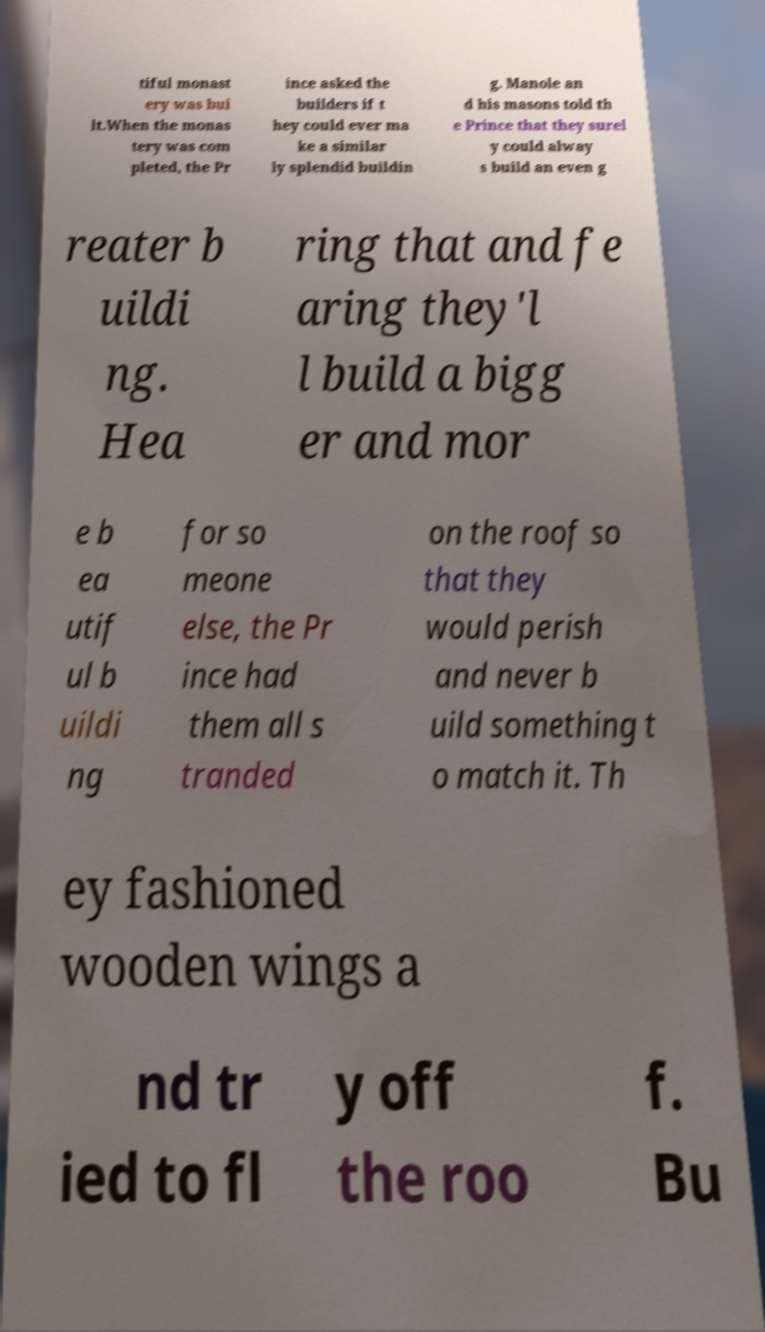Could you extract and type out the text from this image? tiful monast ery was bui lt.When the monas tery was com pleted, the Pr ince asked the builders if t hey could ever ma ke a similar ly splendid buildin g. Manole an d his masons told th e Prince that they surel y could alway s build an even g reater b uildi ng. Hea ring that and fe aring they'l l build a bigg er and mor e b ea utif ul b uildi ng for so meone else, the Pr ince had them all s tranded on the roof so that they would perish and never b uild something t o match it. Th ey fashioned wooden wings a nd tr ied to fl y off the roo f. Bu 